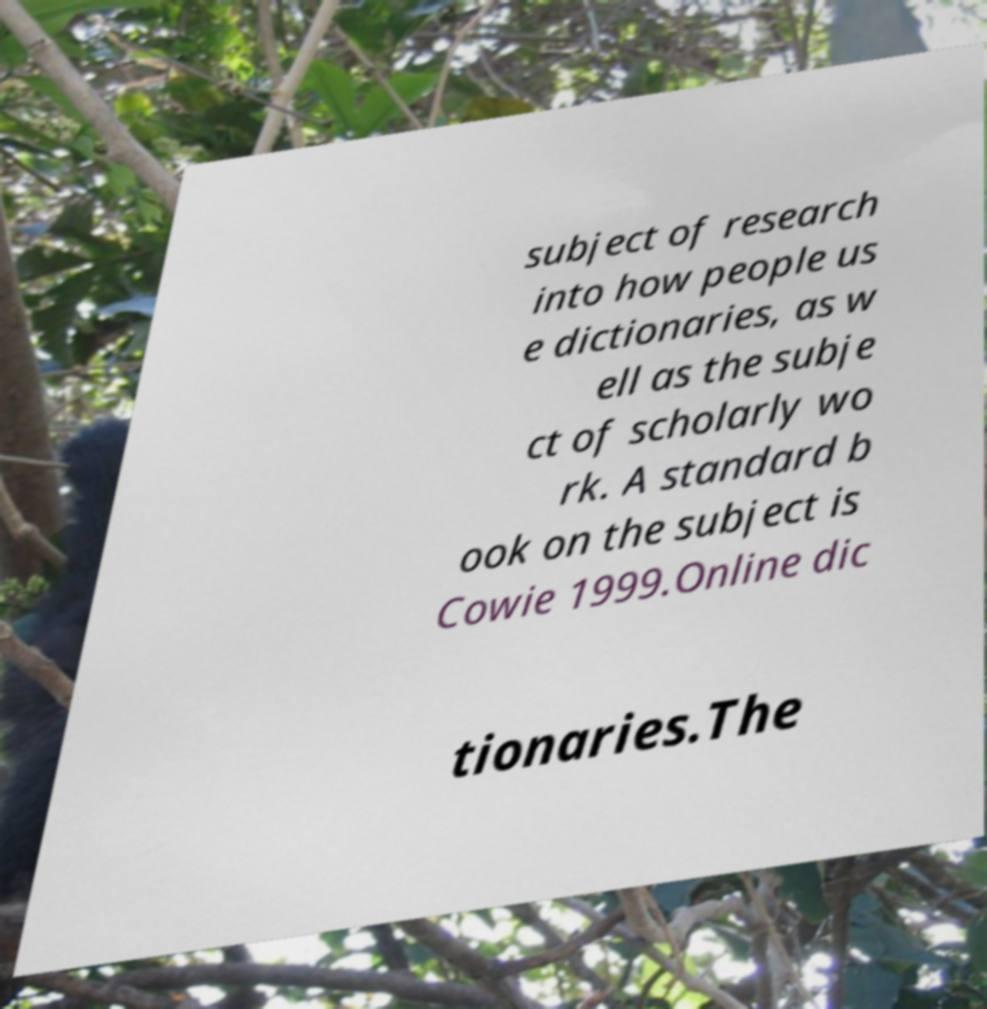There's text embedded in this image that I need extracted. Can you transcribe it verbatim? subject of research into how people us e dictionaries, as w ell as the subje ct of scholarly wo rk. A standard b ook on the subject is Cowie 1999.Online dic tionaries.The 